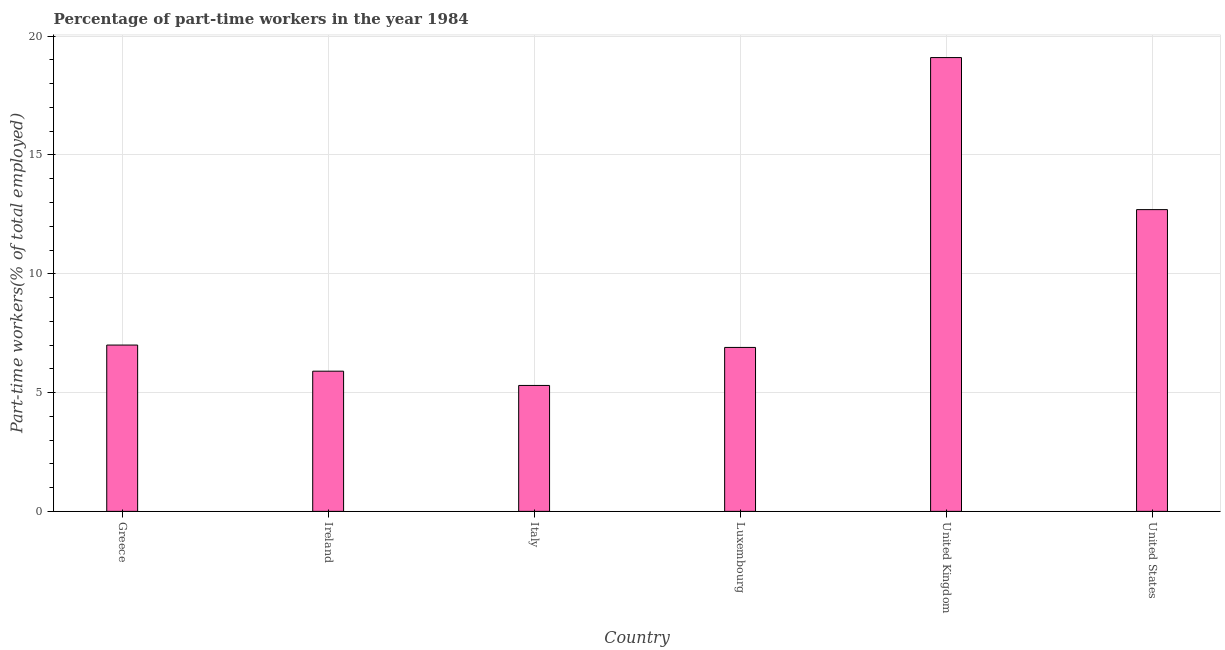Does the graph contain any zero values?
Keep it short and to the point. No. Does the graph contain grids?
Provide a short and direct response. Yes. What is the title of the graph?
Ensure brevity in your answer.  Percentage of part-time workers in the year 1984. What is the label or title of the X-axis?
Give a very brief answer. Country. What is the label or title of the Y-axis?
Your answer should be very brief. Part-time workers(% of total employed). What is the percentage of part-time workers in United Kingdom?
Give a very brief answer. 19.1. Across all countries, what is the maximum percentage of part-time workers?
Offer a terse response. 19.1. Across all countries, what is the minimum percentage of part-time workers?
Give a very brief answer. 5.3. What is the sum of the percentage of part-time workers?
Offer a very short reply. 56.9. What is the average percentage of part-time workers per country?
Give a very brief answer. 9.48. What is the median percentage of part-time workers?
Provide a short and direct response. 6.95. What is the ratio of the percentage of part-time workers in Italy to that in United Kingdom?
Your response must be concise. 0.28. What is the difference between the highest and the lowest percentage of part-time workers?
Give a very brief answer. 13.8. Are all the bars in the graph horizontal?
Your answer should be compact. No. How many countries are there in the graph?
Your response must be concise. 6. What is the Part-time workers(% of total employed) of Ireland?
Offer a terse response. 5.9. What is the Part-time workers(% of total employed) in Italy?
Ensure brevity in your answer.  5.3. What is the Part-time workers(% of total employed) of Luxembourg?
Keep it short and to the point. 6.9. What is the Part-time workers(% of total employed) in United Kingdom?
Make the answer very short. 19.1. What is the Part-time workers(% of total employed) in United States?
Offer a terse response. 12.7. What is the difference between the Part-time workers(% of total employed) in Greece and Italy?
Make the answer very short. 1.7. What is the difference between the Part-time workers(% of total employed) in Greece and United Kingdom?
Your answer should be very brief. -12.1. What is the difference between the Part-time workers(% of total employed) in Greece and United States?
Offer a very short reply. -5.7. What is the difference between the Part-time workers(% of total employed) in Ireland and Luxembourg?
Provide a short and direct response. -1. What is the difference between the Part-time workers(% of total employed) in Ireland and United States?
Your answer should be very brief. -6.8. What is the difference between the Part-time workers(% of total employed) in Italy and United Kingdom?
Make the answer very short. -13.8. What is the difference between the Part-time workers(% of total employed) in United Kingdom and United States?
Provide a short and direct response. 6.4. What is the ratio of the Part-time workers(% of total employed) in Greece to that in Ireland?
Offer a very short reply. 1.19. What is the ratio of the Part-time workers(% of total employed) in Greece to that in Italy?
Offer a terse response. 1.32. What is the ratio of the Part-time workers(% of total employed) in Greece to that in Luxembourg?
Offer a terse response. 1.01. What is the ratio of the Part-time workers(% of total employed) in Greece to that in United Kingdom?
Your response must be concise. 0.37. What is the ratio of the Part-time workers(% of total employed) in Greece to that in United States?
Provide a succinct answer. 0.55. What is the ratio of the Part-time workers(% of total employed) in Ireland to that in Italy?
Make the answer very short. 1.11. What is the ratio of the Part-time workers(% of total employed) in Ireland to that in Luxembourg?
Offer a terse response. 0.85. What is the ratio of the Part-time workers(% of total employed) in Ireland to that in United Kingdom?
Keep it short and to the point. 0.31. What is the ratio of the Part-time workers(% of total employed) in Ireland to that in United States?
Ensure brevity in your answer.  0.47. What is the ratio of the Part-time workers(% of total employed) in Italy to that in Luxembourg?
Provide a short and direct response. 0.77. What is the ratio of the Part-time workers(% of total employed) in Italy to that in United Kingdom?
Your answer should be compact. 0.28. What is the ratio of the Part-time workers(% of total employed) in Italy to that in United States?
Make the answer very short. 0.42. What is the ratio of the Part-time workers(% of total employed) in Luxembourg to that in United Kingdom?
Your response must be concise. 0.36. What is the ratio of the Part-time workers(% of total employed) in Luxembourg to that in United States?
Offer a terse response. 0.54. What is the ratio of the Part-time workers(% of total employed) in United Kingdom to that in United States?
Give a very brief answer. 1.5. 